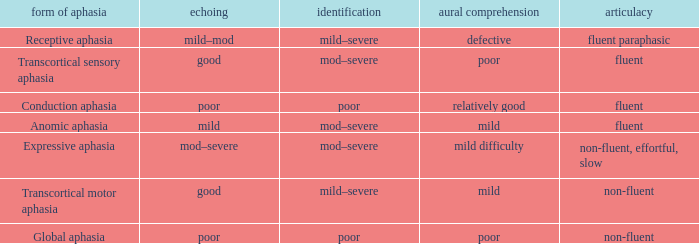Name the fluency for transcortical sensory aphasia Fluent. 